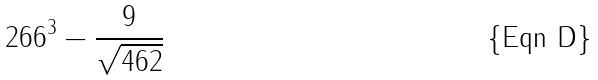<formula> <loc_0><loc_0><loc_500><loc_500>2 6 6 ^ { 3 } - \frac { 9 } { \sqrt { 4 6 2 } }</formula> 